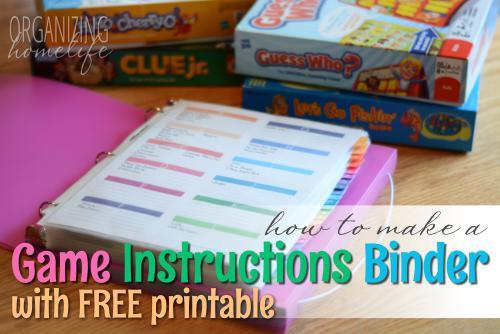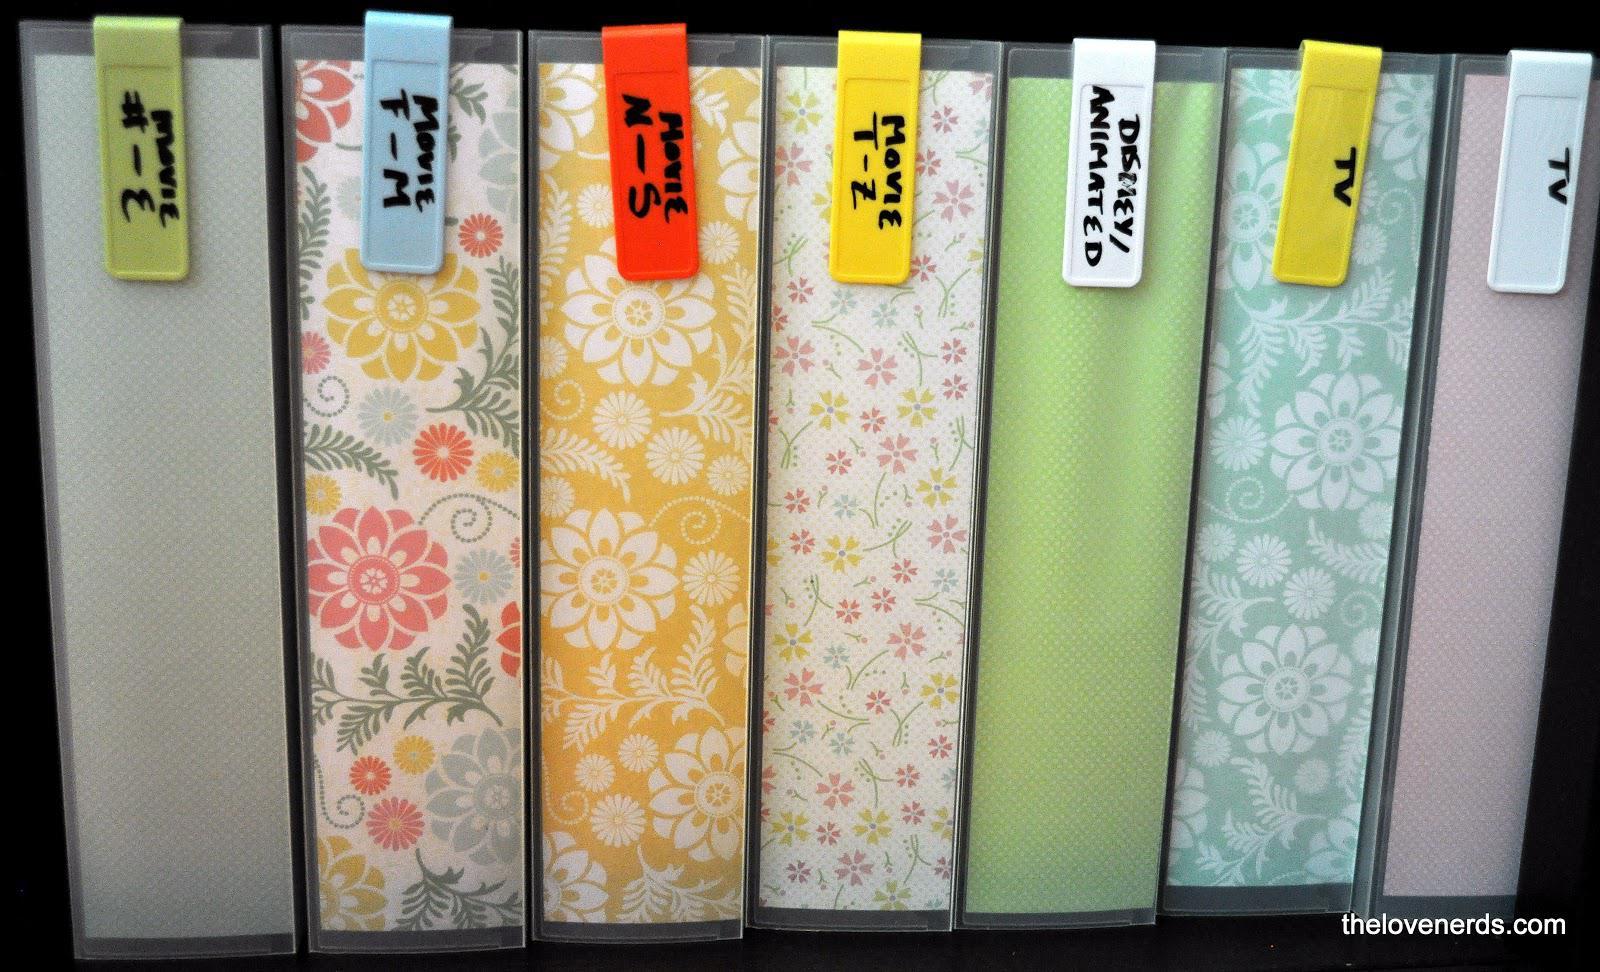The first image is the image on the left, the second image is the image on the right. Considering the images on both sides, is "There is an open binder." valid? Answer yes or no. Yes. The first image is the image on the left, the second image is the image on the right. Assess this claim about the two images: "At least one binder with pages in it is opened.". Correct or not? Answer yes or no. Yes. 